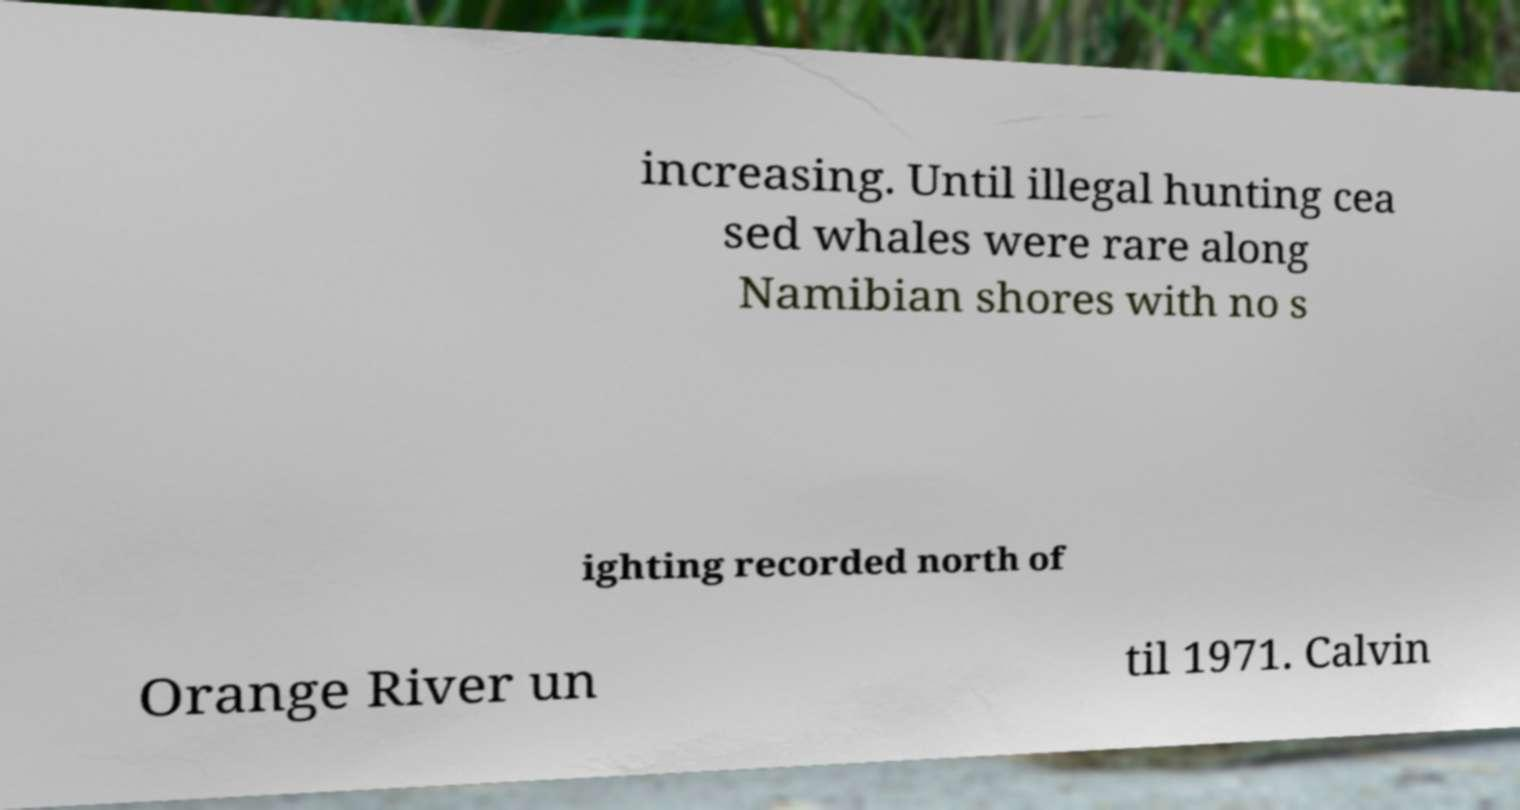Could you assist in decoding the text presented in this image and type it out clearly? increasing. Until illegal hunting cea sed whales were rare along Namibian shores with no s ighting recorded north of Orange River un til 1971. Calvin 